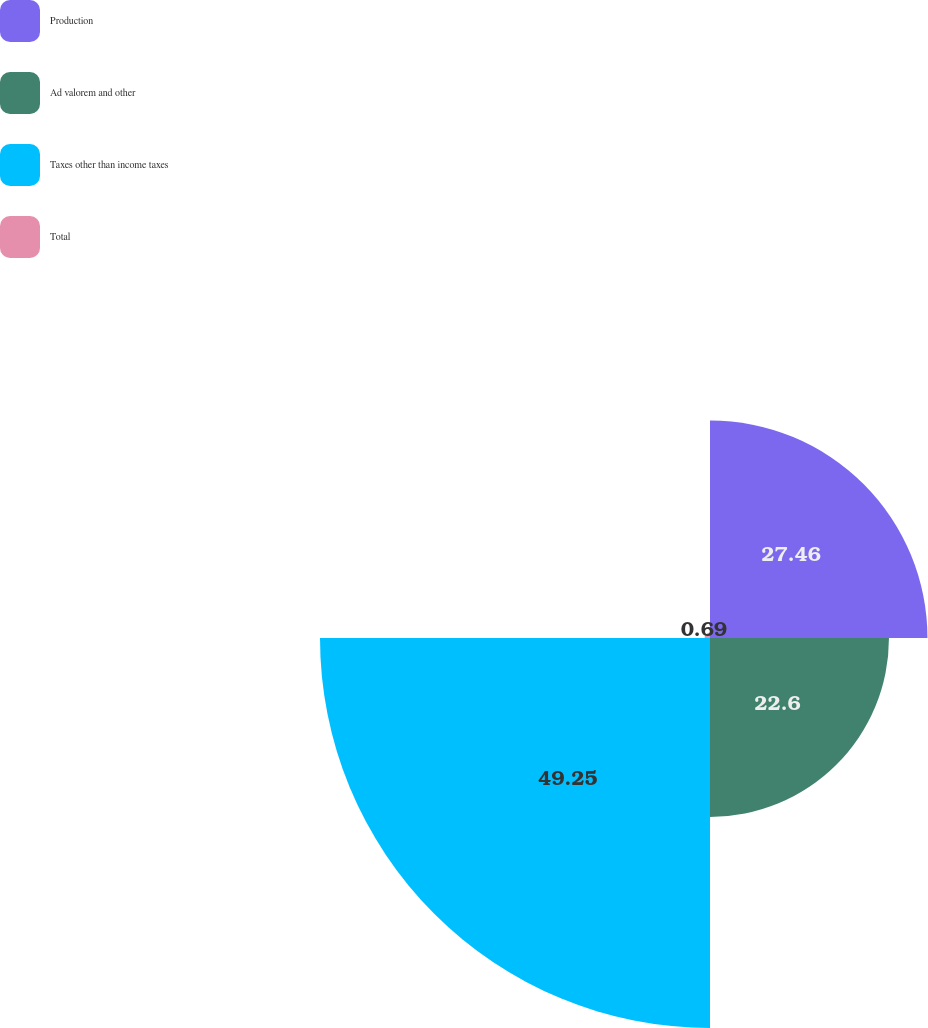Convert chart. <chart><loc_0><loc_0><loc_500><loc_500><pie_chart><fcel>Production<fcel>Ad valorem and other<fcel>Taxes other than income taxes<fcel>Total<nl><fcel>27.46%<fcel>22.6%<fcel>49.25%<fcel>0.69%<nl></chart> 